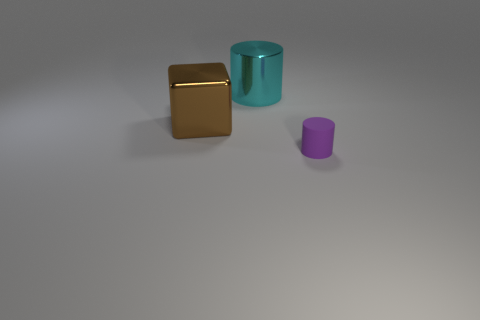What number of large cubes have the same material as the purple thing?
Provide a succinct answer. 0. There is a cylinder in front of the cylinder that is behind the small purple cylinder; what is its size?
Your answer should be very brief. Small. What color is the thing that is on the right side of the large brown shiny cube and in front of the cyan metallic thing?
Your answer should be very brief. Purple. Is the matte object the same shape as the big cyan thing?
Your answer should be compact. Yes. What shape is the metal object in front of the object that is behind the brown metallic object?
Provide a succinct answer. Cube. There is a brown thing; is it the same shape as the thing behind the big brown cube?
Give a very brief answer. No. There is a object that is the same size as the cube; what is its color?
Your answer should be compact. Cyan. Is the number of cubes behind the small object less than the number of tiny matte objects that are behind the shiny block?
Your answer should be compact. No. What shape is the metal object in front of the cylinder that is left of the object that is in front of the cube?
Give a very brief answer. Cube. There is a cylinder that is to the left of the tiny purple cylinder; is its color the same as the cylinder in front of the brown object?
Provide a short and direct response. No. 